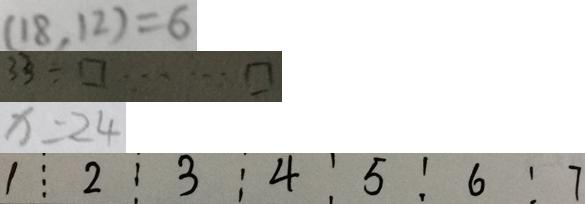Convert formula to latex. <formula><loc_0><loc_0><loc_500><loc_500>( 1 8 , 1 2 ) = 6 
 3 3 \div \square \cdots \square 
 x = 2 4 
 1 \vdots 2 \vdots 3 : 4 5 : 6 : 7</formula> 